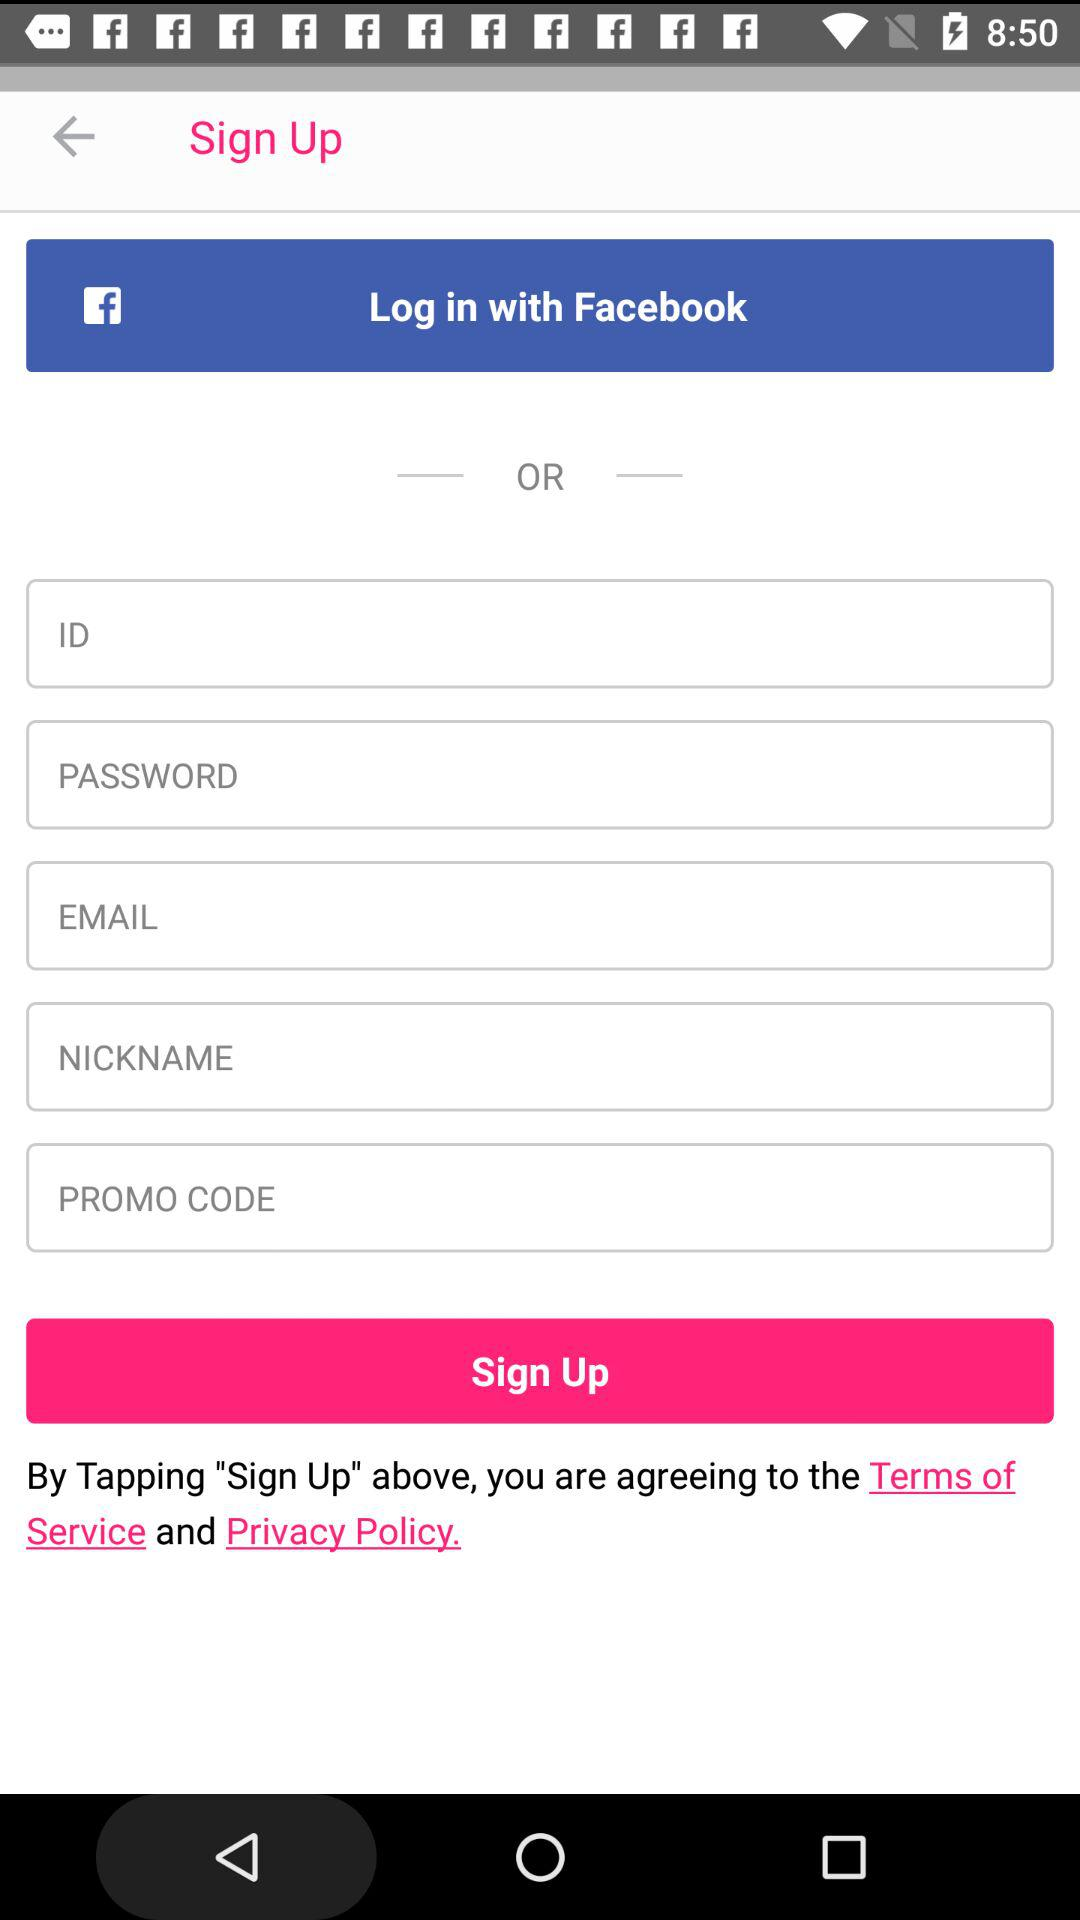Through what application can the user log in? The user can log in through "Facebook". 